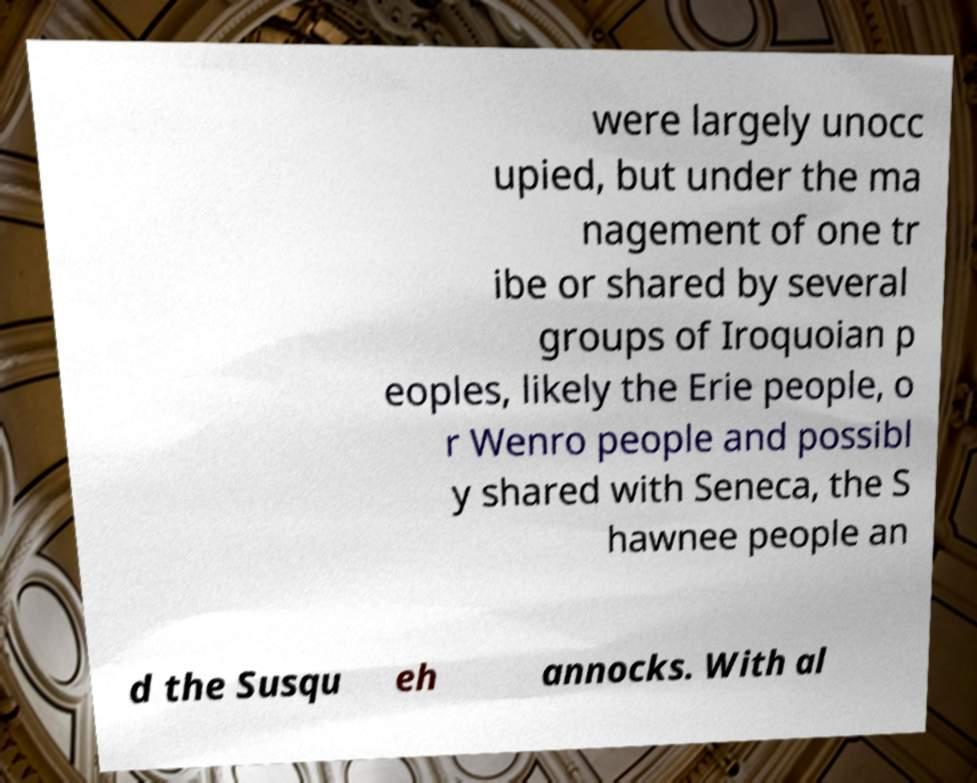Could you extract and type out the text from this image? were largely unocc upied, but under the ma nagement of one tr ibe or shared by several groups of Iroquoian p eoples, likely the Erie people, o r Wenro people and possibl y shared with Seneca, the S hawnee people an d the Susqu eh annocks. With al 